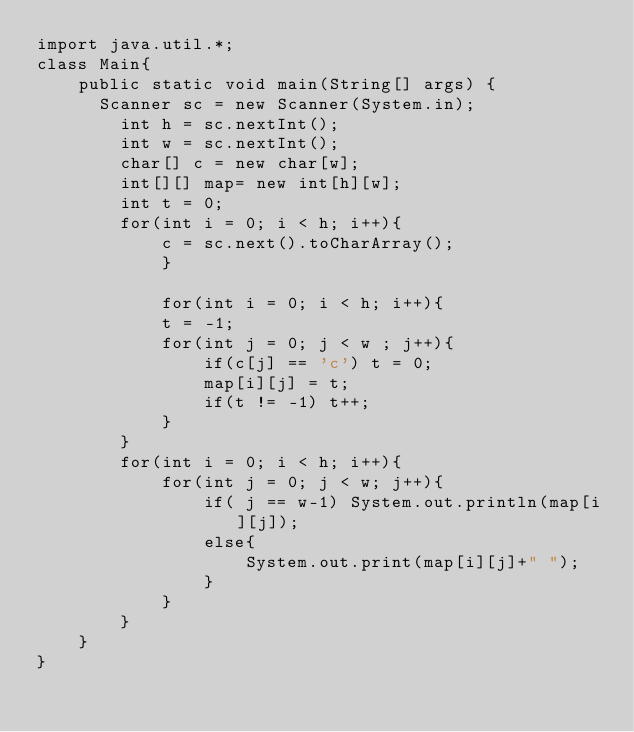<code> <loc_0><loc_0><loc_500><loc_500><_Java_>import java.util.*;
class Main{
    public static void main(String[] args) {
    	Scanner sc = new Scanner(System.in);
        int h = sc.nextInt();
        int w = sc.nextInt();
        char[] c = new char[w];
        int[][] map= new int[h][w];
        int t = 0;
        for(int i = 0; i < h; i++){
            c = sc.next().toCharArray();
            }
        
            for(int i = 0; i < h; i++){
            t = -1;
            for(int j = 0; j < w ; j++){
                if(c[j] == 'c') t = 0;
                map[i][j] = t;
                if(t != -1) t++;
            }
        }
        for(int i = 0; i < h; i++){
            for(int j = 0; j < w; j++){
                if( j == w-1) System.out.println(map[i][j]);
                else{
                    System.out.print(map[i][j]+" ");
                }
            }
        }
    }
}</code> 